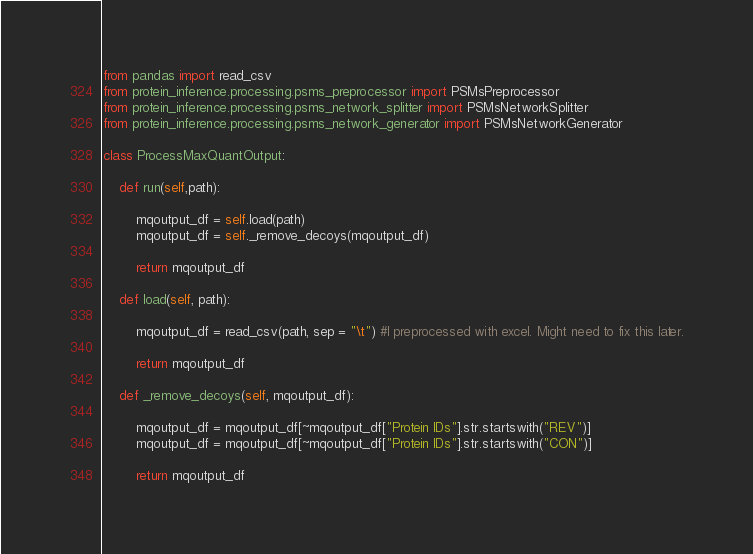Convert code to text. <code><loc_0><loc_0><loc_500><loc_500><_Python_>from pandas import read_csv
from protein_inference.processing.psms_preprocessor import PSMsPreprocessor
from protein_inference.processing.psms_network_splitter import PSMsNetworkSplitter
from protein_inference.processing.psms_network_generator import PSMsNetworkGenerator

class ProcessMaxQuantOutput:

    def run(self,path):

        mqoutput_df = self.load(path)
        mqoutput_df = self._remove_decoys(mqoutput_df)

        return mqoutput_df

    def load(self, path):

        mqoutput_df = read_csv(path, sep = "\t") #I preprocessed with excel. Might need to fix this later.

        return mqoutput_df

    def _remove_decoys(self, mqoutput_df):

        mqoutput_df = mqoutput_df[~mqoutput_df["Protein IDs"].str.startswith("REV")]
        mqoutput_df = mqoutput_df[~mqoutput_df["Protein IDs"].str.startswith("CON")]

        return mqoutput_df
</code> 